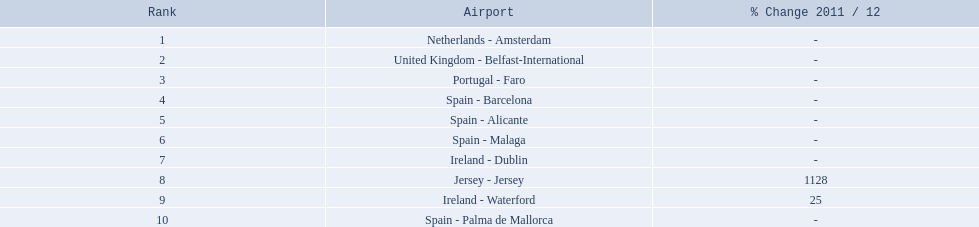What are all the passengers handled values for london southend airport? 105,349, 92,502, 71,676, 66,565, 64,090, 59,175, 35,524, 35,169, 31,907, 27,718. Which are 30,000 or less? 27,718. What airport is this for? Spain - Palma de Mallorca. Which airports are in europe? Netherlands - Amsterdam, United Kingdom - Belfast-International, Portugal - Faro, Spain - Barcelona, Spain - Alicante, Spain - Malaga, Ireland - Dublin, Ireland - Waterford, Spain - Palma de Mallorca. Which one is from portugal? Portugal - Faro. 